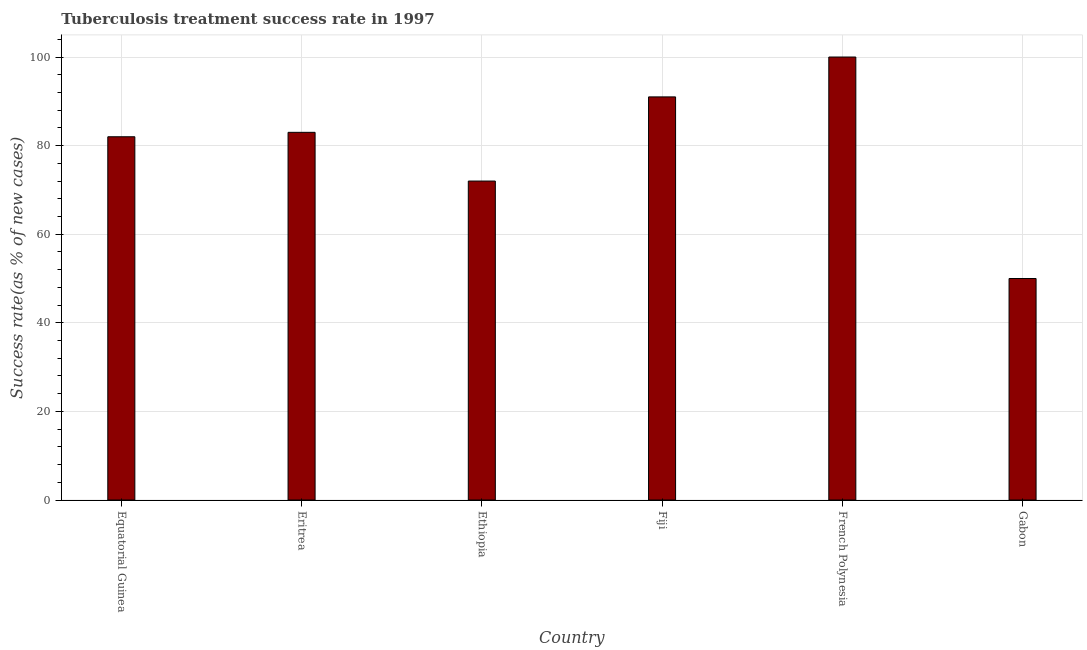Does the graph contain any zero values?
Offer a terse response. No. Does the graph contain grids?
Make the answer very short. Yes. What is the title of the graph?
Give a very brief answer. Tuberculosis treatment success rate in 1997. What is the label or title of the X-axis?
Provide a short and direct response. Country. What is the label or title of the Y-axis?
Offer a very short reply. Success rate(as % of new cases). What is the tuberculosis treatment success rate in Fiji?
Offer a terse response. 91. Across all countries, what is the maximum tuberculosis treatment success rate?
Provide a succinct answer. 100. Across all countries, what is the minimum tuberculosis treatment success rate?
Give a very brief answer. 50. In which country was the tuberculosis treatment success rate maximum?
Provide a short and direct response. French Polynesia. In which country was the tuberculosis treatment success rate minimum?
Offer a very short reply. Gabon. What is the sum of the tuberculosis treatment success rate?
Your answer should be very brief. 478. What is the average tuberculosis treatment success rate per country?
Ensure brevity in your answer.  79. What is the median tuberculosis treatment success rate?
Make the answer very short. 82.5. What is the ratio of the tuberculosis treatment success rate in Fiji to that in Gabon?
Provide a short and direct response. 1.82. Is the tuberculosis treatment success rate in Eritrea less than that in Gabon?
Offer a very short reply. No. Is the difference between the tuberculosis treatment success rate in Equatorial Guinea and Gabon greater than the difference between any two countries?
Your response must be concise. No. What is the Success rate(as % of new cases) of Equatorial Guinea?
Ensure brevity in your answer.  82. What is the Success rate(as % of new cases) in Eritrea?
Make the answer very short. 83. What is the Success rate(as % of new cases) of Fiji?
Give a very brief answer. 91. What is the difference between the Success rate(as % of new cases) in Equatorial Guinea and Eritrea?
Offer a terse response. -1. What is the difference between the Success rate(as % of new cases) in Equatorial Guinea and French Polynesia?
Ensure brevity in your answer.  -18. What is the difference between the Success rate(as % of new cases) in Eritrea and Fiji?
Ensure brevity in your answer.  -8. What is the difference between the Success rate(as % of new cases) in Eritrea and Gabon?
Your response must be concise. 33. What is the difference between the Success rate(as % of new cases) in Ethiopia and Fiji?
Provide a succinct answer. -19. What is the difference between the Success rate(as % of new cases) in Ethiopia and Gabon?
Your answer should be very brief. 22. What is the difference between the Success rate(as % of new cases) in French Polynesia and Gabon?
Give a very brief answer. 50. What is the ratio of the Success rate(as % of new cases) in Equatorial Guinea to that in Eritrea?
Provide a short and direct response. 0.99. What is the ratio of the Success rate(as % of new cases) in Equatorial Guinea to that in Ethiopia?
Keep it short and to the point. 1.14. What is the ratio of the Success rate(as % of new cases) in Equatorial Guinea to that in Fiji?
Your response must be concise. 0.9. What is the ratio of the Success rate(as % of new cases) in Equatorial Guinea to that in French Polynesia?
Provide a short and direct response. 0.82. What is the ratio of the Success rate(as % of new cases) in Equatorial Guinea to that in Gabon?
Your answer should be compact. 1.64. What is the ratio of the Success rate(as % of new cases) in Eritrea to that in Ethiopia?
Keep it short and to the point. 1.15. What is the ratio of the Success rate(as % of new cases) in Eritrea to that in Fiji?
Make the answer very short. 0.91. What is the ratio of the Success rate(as % of new cases) in Eritrea to that in French Polynesia?
Your response must be concise. 0.83. What is the ratio of the Success rate(as % of new cases) in Eritrea to that in Gabon?
Provide a succinct answer. 1.66. What is the ratio of the Success rate(as % of new cases) in Ethiopia to that in Fiji?
Make the answer very short. 0.79. What is the ratio of the Success rate(as % of new cases) in Ethiopia to that in French Polynesia?
Offer a very short reply. 0.72. What is the ratio of the Success rate(as % of new cases) in Ethiopia to that in Gabon?
Provide a succinct answer. 1.44. What is the ratio of the Success rate(as % of new cases) in Fiji to that in French Polynesia?
Your answer should be very brief. 0.91. What is the ratio of the Success rate(as % of new cases) in Fiji to that in Gabon?
Your response must be concise. 1.82. What is the ratio of the Success rate(as % of new cases) in French Polynesia to that in Gabon?
Keep it short and to the point. 2. 